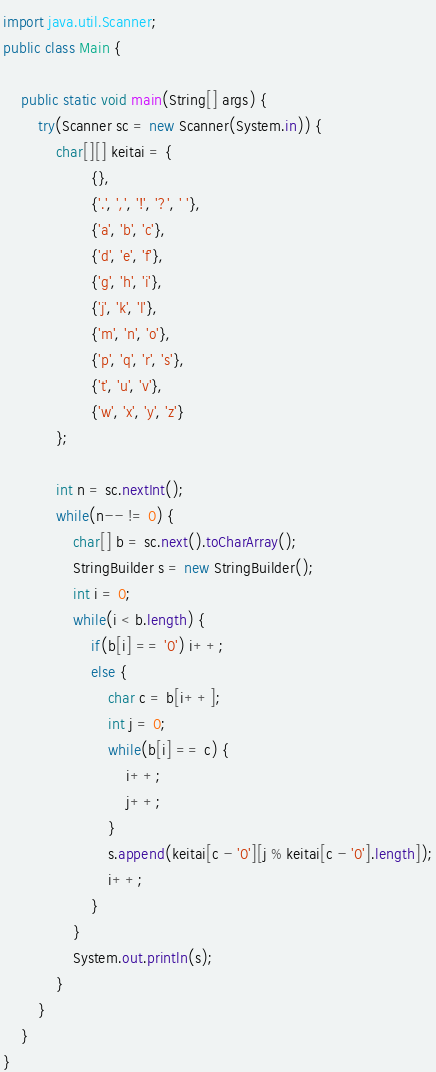Convert code to text. <code><loc_0><loc_0><loc_500><loc_500><_Java_>import java.util.Scanner;
public class Main {
	
	public static void main(String[] args) {
		try(Scanner sc = new Scanner(System.in)) {
			char[][] keitai = {
					{},
					{'.', ',', '!', '?', ' '},
					{'a', 'b', 'c'},
					{'d', 'e', 'f'},
					{'g', 'h', 'i'},
					{'j', 'k', 'l'},
					{'m', 'n', 'o'},
					{'p', 'q', 'r', 's'},
					{'t', 'u', 'v'},
					{'w', 'x', 'y', 'z'}
			};
			
			int n = sc.nextInt();
			while(n-- != 0) {
				char[] b = sc.next().toCharArray();
				StringBuilder s = new StringBuilder();
				int i = 0;
				while(i < b.length) {
					if(b[i] == '0') i++;
					else {
						char c = b[i++];
						int j = 0;
						while(b[i] == c) {
							i++;
							j++;
						}
						s.append(keitai[c - '0'][j % keitai[c - '0'].length]);
						i++;
					}
				}
				System.out.println(s);
			}
		}
	}
}

</code> 